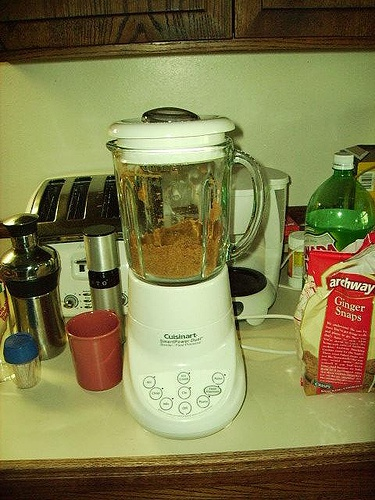Describe the objects in this image and their specific colors. I can see bottle in black, darkgreen, and olive tones, bottle in black, darkgreen, and olive tones, and cup in black, maroon, and brown tones in this image. 